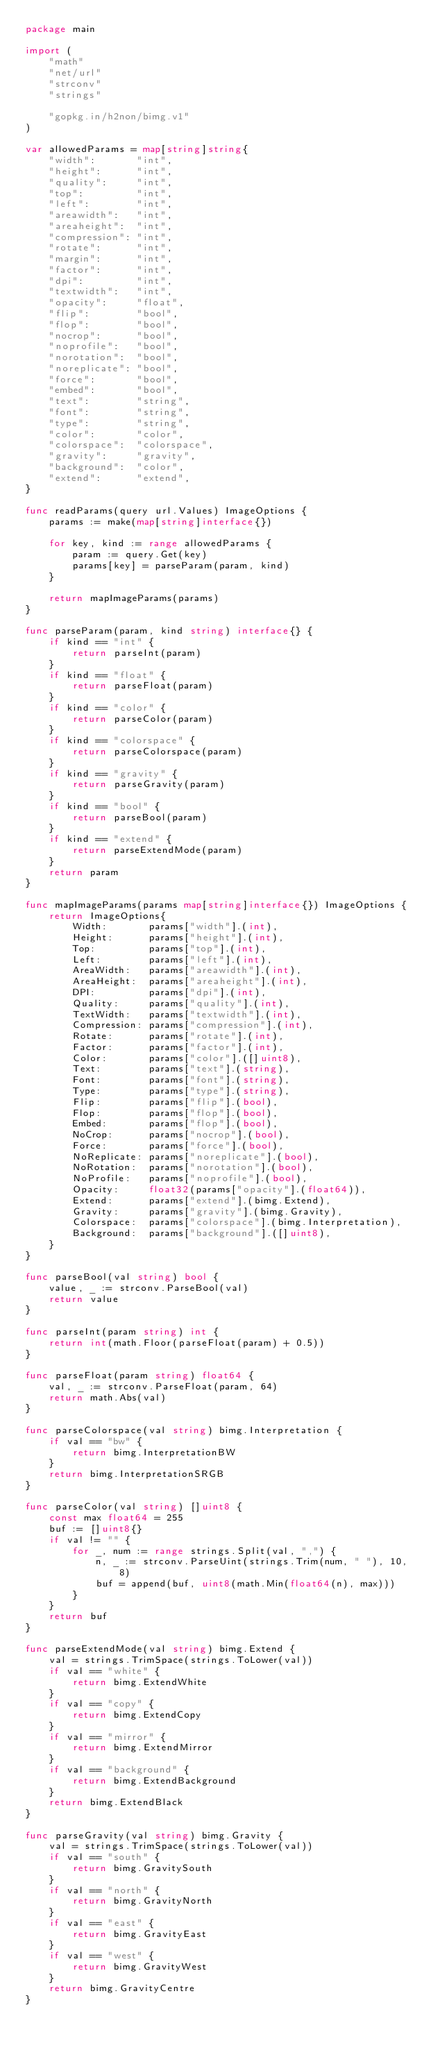Convert code to text. <code><loc_0><loc_0><loc_500><loc_500><_Go_>package main

import (
	"math"
	"net/url"
	"strconv"
	"strings"

	"gopkg.in/h2non/bimg.v1"
)

var allowedParams = map[string]string{
	"width":       "int",
	"height":      "int",
	"quality":     "int",
	"top":         "int",
	"left":        "int",
	"areawidth":   "int",
	"areaheight":  "int",
	"compression": "int",
	"rotate":      "int",
	"margin":      "int",
	"factor":      "int",
	"dpi":         "int",
	"textwidth":   "int",
	"opacity":     "float",
	"flip":        "bool",
	"flop":        "bool",
	"nocrop":      "bool",
	"noprofile":   "bool",
	"norotation":  "bool",
	"noreplicate": "bool",
	"force":       "bool",
	"embed":       "bool",
	"text":        "string",
	"font":        "string",
	"type":        "string",
	"color":       "color",
	"colorspace":  "colorspace",
	"gravity":     "gravity",
	"background":  "color",
	"extend":      "extend",
}

func readParams(query url.Values) ImageOptions {
	params := make(map[string]interface{})

	for key, kind := range allowedParams {
		param := query.Get(key)
		params[key] = parseParam(param, kind)
	}

	return mapImageParams(params)
}

func parseParam(param, kind string) interface{} {
	if kind == "int" {
		return parseInt(param)
	}
	if kind == "float" {
		return parseFloat(param)
	}
	if kind == "color" {
		return parseColor(param)
	}
	if kind == "colorspace" {
		return parseColorspace(param)
	}
	if kind == "gravity" {
		return parseGravity(param)
	}
	if kind == "bool" {
		return parseBool(param)
	}
	if kind == "extend" {
		return parseExtendMode(param)
	}
	return param
}

func mapImageParams(params map[string]interface{}) ImageOptions {
	return ImageOptions{
		Width:       params["width"].(int),
		Height:      params["height"].(int),
		Top:         params["top"].(int),
		Left:        params["left"].(int),
		AreaWidth:   params["areawidth"].(int),
		AreaHeight:  params["areaheight"].(int),
		DPI:         params["dpi"].(int),
		Quality:     params["quality"].(int),
		TextWidth:   params["textwidth"].(int),
		Compression: params["compression"].(int),
		Rotate:      params["rotate"].(int),
		Factor:      params["factor"].(int),
		Color:       params["color"].([]uint8),
		Text:        params["text"].(string),
		Font:        params["font"].(string),
		Type:        params["type"].(string),
		Flip:        params["flip"].(bool),
		Flop:        params["flop"].(bool),
		Embed:       params["flop"].(bool),
		NoCrop:      params["nocrop"].(bool),
		Force:       params["force"].(bool),
		NoReplicate: params["noreplicate"].(bool),
		NoRotation:  params["norotation"].(bool),
		NoProfile:   params["noprofile"].(bool),
		Opacity:     float32(params["opacity"].(float64)),
		Extend:      params["extend"].(bimg.Extend),
		Gravity:     params["gravity"].(bimg.Gravity),
		Colorspace:  params["colorspace"].(bimg.Interpretation),
		Background:  params["background"].([]uint8),
	}
}

func parseBool(val string) bool {
	value, _ := strconv.ParseBool(val)
	return value
}

func parseInt(param string) int {
	return int(math.Floor(parseFloat(param) + 0.5))
}

func parseFloat(param string) float64 {
	val, _ := strconv.ParseFloat(param, 64)
	return math.Abs(val)
}

func parseColorspace(val string) bimg.Interpretation {
	if val == "bw" {
		return bimg.InterpretationBW
	}
	return bimg.InterpretationSRGB
}

func parseColor(val string) []uint8 {
	const max float64 = 255
	buf := []uint8{}
	if val != "" {
		for _, num := range strings.Split(val, ",") {
			n, _ := strconv.ParseUint(strings.Trim(num, " "), 10, 8)
			buf = append(buf, uint8(math.Min(float64(n), max)))
		}
	}
	return buf
}

func parseExtendMode(val string) bimg.Extend {
	val = strings.TrimSpace(strings.ToLower(val))
	if val == "white" {
		return bimg.ExtendWhite
	}
	if val == "copy" {
		return bimg.ExtendCopy
	}
	if val == "mirror" {
		return bimg.ExtendMirror
	}
	if val == "background" {
		return bimg.ExtendBackground
	}
	return bimg.ExtendBlack
}

func parseGravity(val string) bimg.Gravity {
	val = strings.TrimSpace(strings.ToLower(val))
	if val == "south" {
		return bimg.GravitySouth
	}
	if val == "north" {
		return bimg.GravityNorth
	}
	if val == "east" {
		return bimg.GravityEast
	}
	if val == "west" {
		return bimg.GravityWest
	}
	return bimg.GravityCentre
}
</code> 